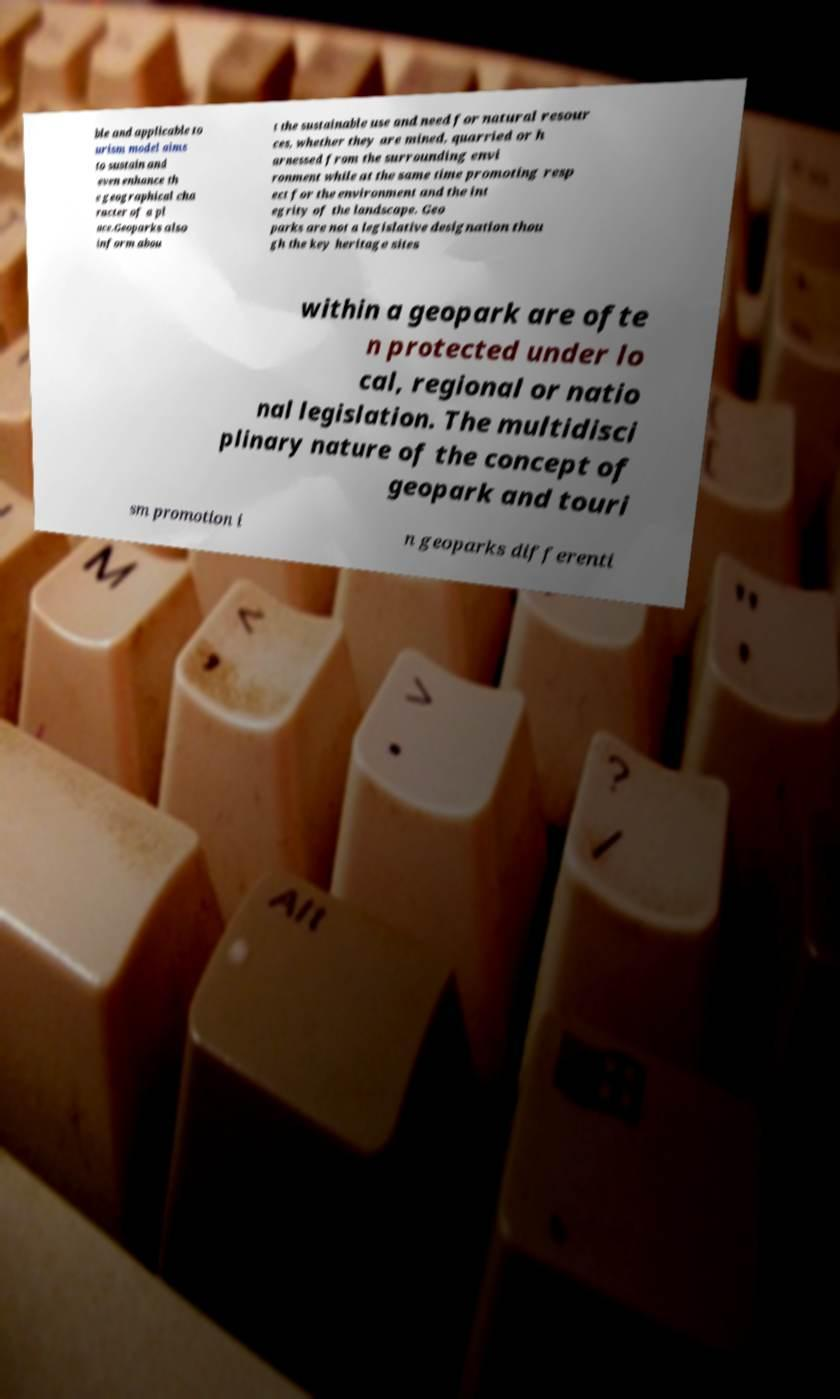Please identify and transcribe the text found in this image. ble and applicable to urism model aims to sustain and even enhance th e geographical cha racter of a pl ace.Geoparks also inform abou t the sustainable use and need for natural resour ces, whether they are mined, quarried or h arnessed from the surrounding envi ronment while at the same time promoting resp ect for the environment and the int egrity of the landscape. Geo parks are not a legislative designation thou gh the key heritage sites within a geopark are ofte n protected under lo cal, regional or natio nal legislation. The multidisci plinary nature of the concept of geopark and touri sm promotion i n geoparks differenti 